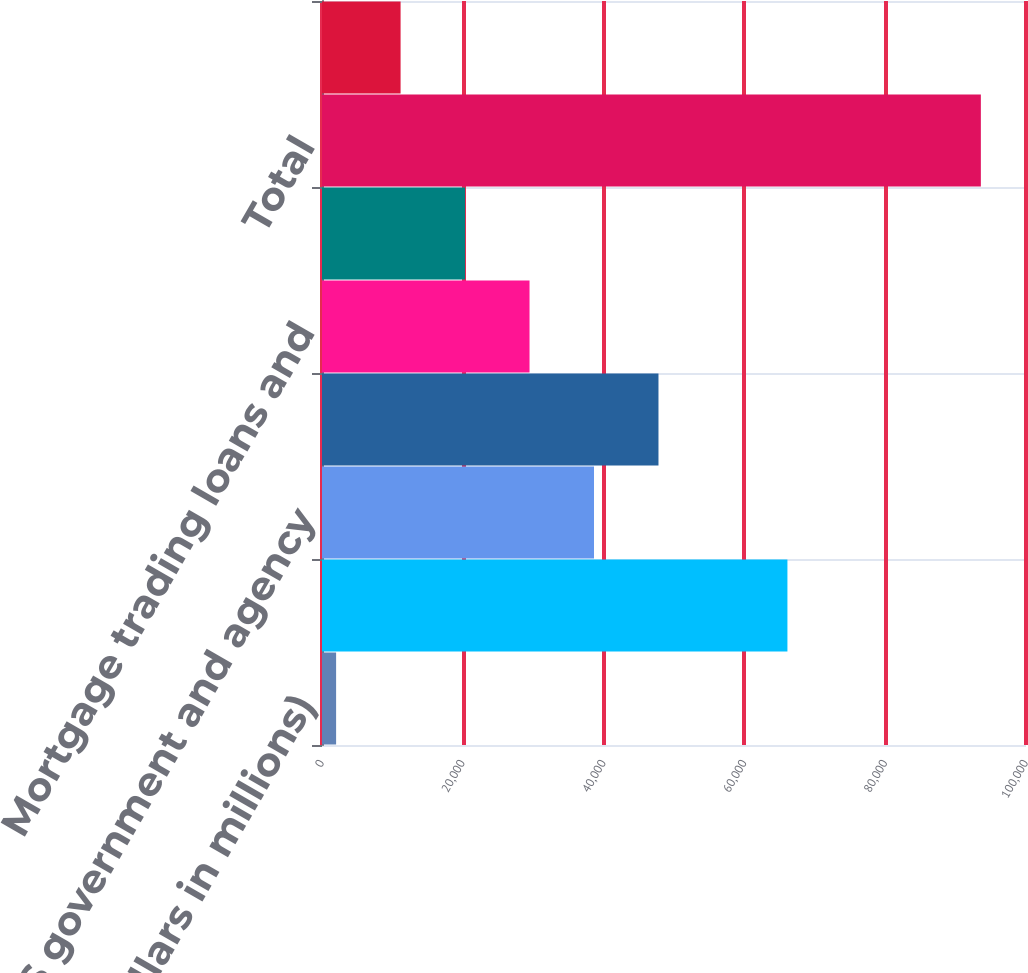Convert chart. <chart><loc_0><loc_0><loc_500><loc_500><bar_chart><fcel>(Dollars in millions)<fcel>Corporate securities trading<fcel>US government and agency<fcel>Equity securities<fcel>Mortgage trading loans and<fcel>Foreign sovereign debt<fcel>Total<fcel>Corporate securities and other<nl><fcel>2004<fcel>66112.1<fcel>38637.2<fcel>47795.5<fcel>29478.9<fcel>20320.6<fcel>93587<fcel>11162.3<nl></chart> 